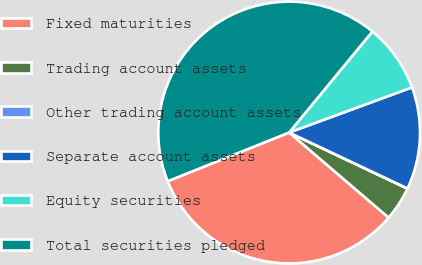<chart> <loc_0><loc_0><loc_500><loc_500><pie_chart><fcel>Fixed maturities<fcel>Trading account assets<fcel>Other trading account assets<fcel>Separate account assets<fcel>Equity securities<fcel>Total securities pledged<nl><fcel>32.67%<fcel>4.22%<fcel>0.02%<fcel>12.63%<fcel>8.43%<fcel>42.04%<nl></chart> 